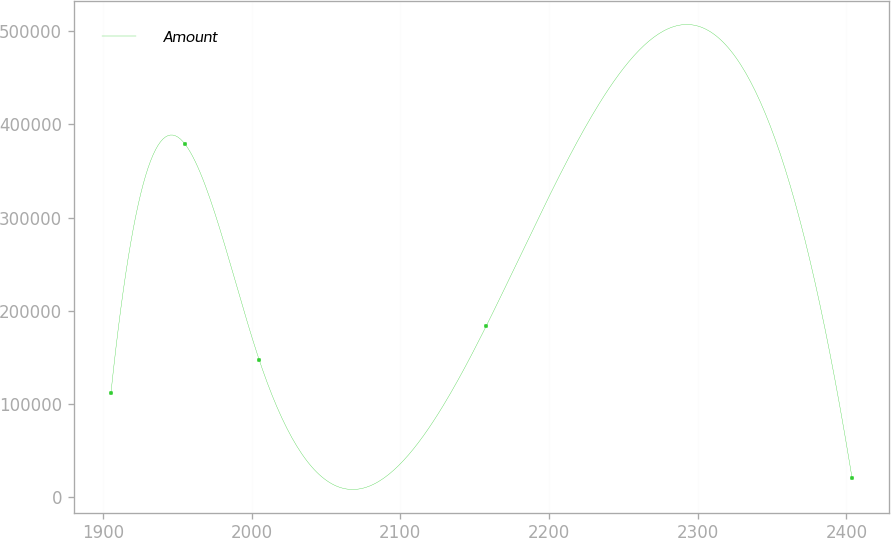Convert chart to OTSL. <chart><loc_0><loc_0><loc_500><loc_500><line_chart><ecel><fcel>Amount<nl><fcel>1905.45<fcel>111643<nl><fcel>1955.29<fcel>378811<nl><fcel>2005.13<fcel>147501<nl><fcel>2157.7<fcel>183359<nl><fcel>2403.83<fcel>20230.3<nl></chart> 